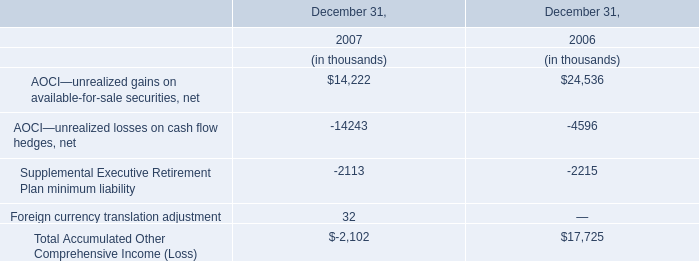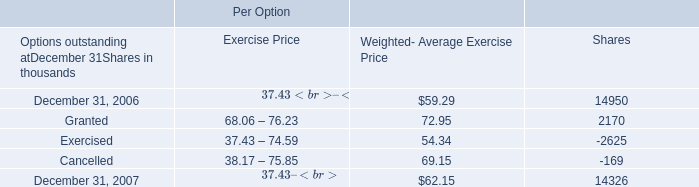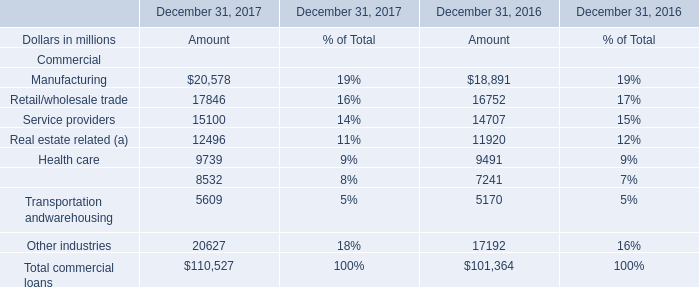What is the average amount of December 31, 2007 of Per Option Shares, and Financial services of December 31, 2017 Amount ? 
Computations: ((14326.0 + 8532.0) / 2)
Answer: 11429.0. What's the sum of Granted of Per Option Shares, and Service providers of December 31, 2016 Amount ? 
Computations: (2170.0 + 14707.0)
Answer: 16877.0. 